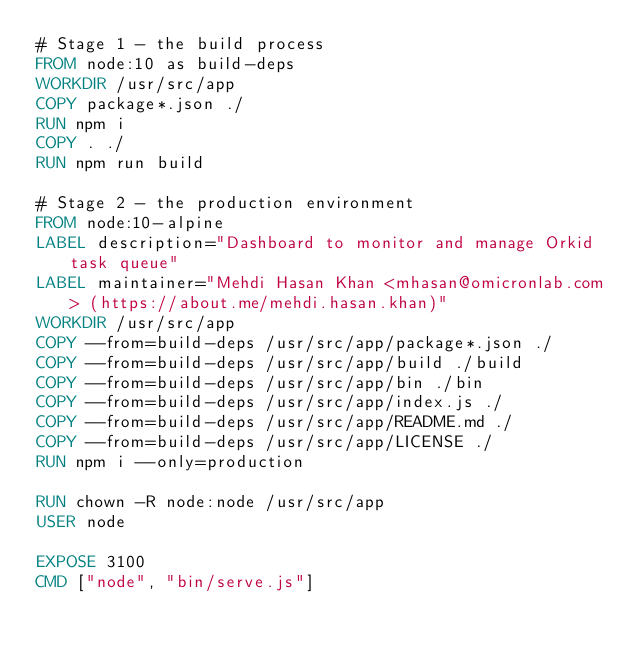Convert code to text. <code><loc_0><loc_0><loc_500><loc_500><_Dockerfile_># Stage 1 - the build process
FROM node:10 as build-deps
WORKDIR /usr/src/app
COPY package*.json ./
RUN npm i
COPY . ./
RUN npm run build

# Stage 2 - the production environment
FROM node:10-alpine
LABEL description="Dashboard to monitor and manage Orkid task queue"
LABEL maintainer="Mehdi Hasan Khan <mhasan@omicronlab.com> (https://about.me/mehdi.hasan.khan)"
WORKDIR /usr/src/app
COPY --from=build-deps /usr/src/app/package*.json ./
COPY --from=build-deps /usr/src/app/build ./build
COPY --from=build-deps /usr/src/app/bin ./bin
COPY --from=build-deps /usr/src/app/index.js ./
COPY --from=build-deps /usr/src/app/README.md ./
COPY --from=build-deps /usr/src/app/LICENSE ./
RUN npm i --only=production

RUN chown -R node:node /usr/src/app
USER node

EXPOSE 3100
CMD ["node", "bin/serve.js"]</code> 